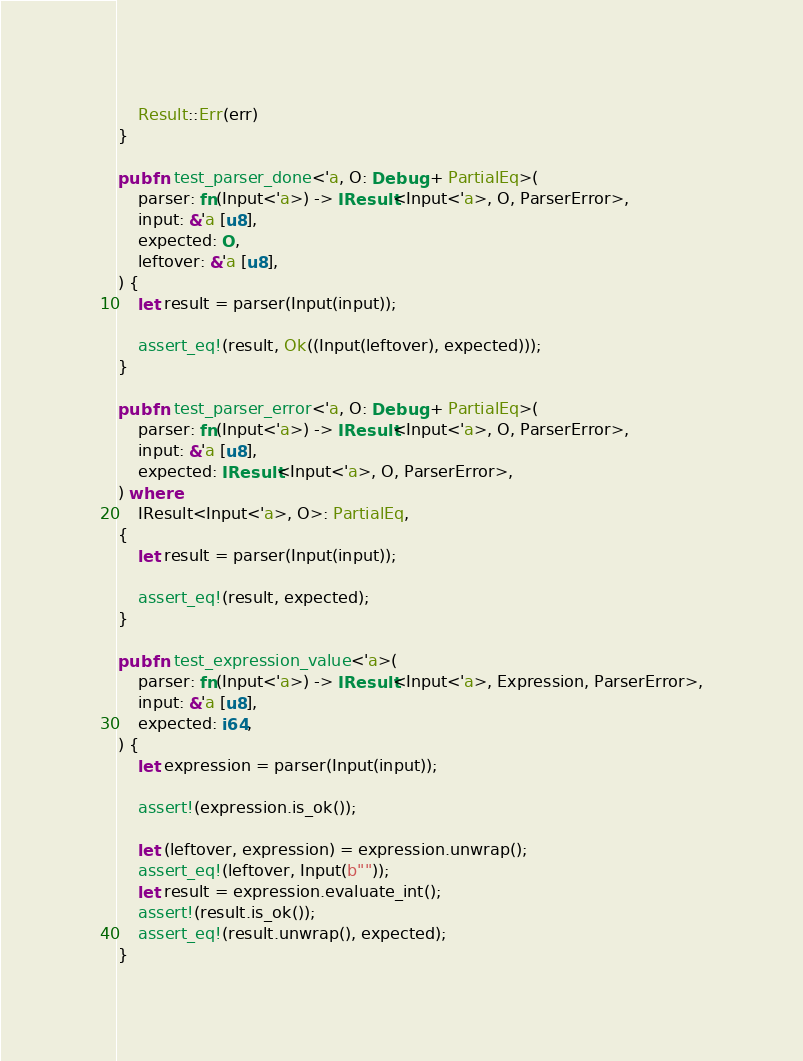<code> <loc_0><loc_0><loc_500><loc_500><_Rust_>
    Result::Err(err)
}

pub fn test_parser_done<'a, O: Debug + PartialEq>(
    parser: fn(Input<'a>) -> IResult<Input<'a>, O, ParserError>,
    input: &'a [u8],
    expected: O,
    leftover: &'a [u8],
) {
    let result = parser(Input(input));

    assert_eq!(result, Ok((Input(leftover), expected)));
}

pub fn test_parser_error<'a, O: Debug + PartialEq>(
    parser: fn(Input<'a>) -> IResult<Input<'a>, O, ParserError>,
    input: &'a [u8],
    expected: IResult<Input<'a>, O, ParserError>,
) where
    IResult<Input<'a>, O>: PartialEq,
{
    let result = parser(Input(input));

    assert_eq!(result, expected);
}

pub fn test_expression_value<'a>(
    parser: fn(Input<'a>) -> IResult<Input<'a>, Expression, ParserError>,
    input: &'a [u8],
    expected: i64,
) {
    let expression = parser(Input(input));

    assert!(expression.is_ok());

    let (leftover, expression) = expression.unwrap();
    assert_eq!(leftover, Input(b""));
    let result = expression.evaluate_int();
    assert!(result.is_ok());
    assert_eq!(result.unwrap(), expected);
}
</code> 